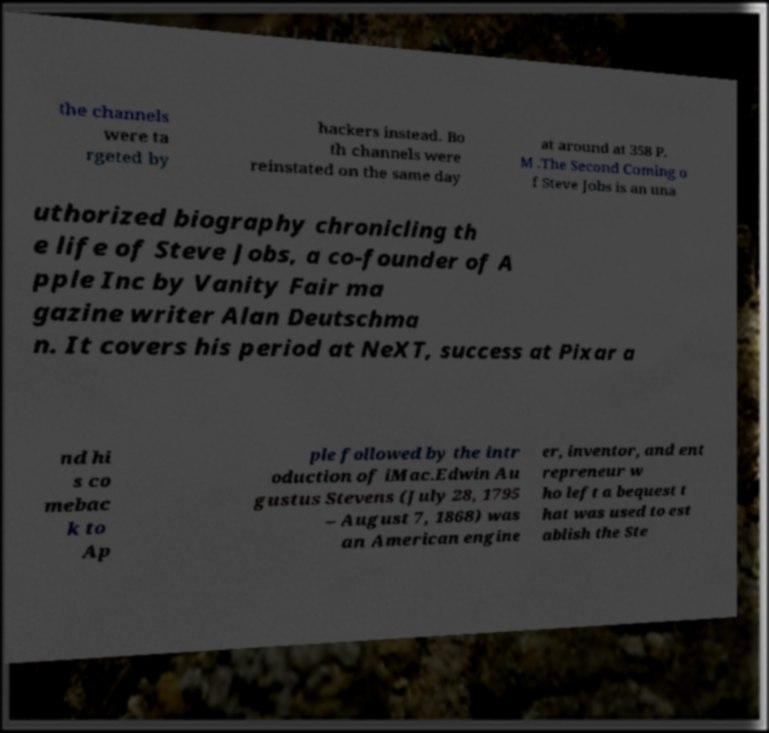Can you accurately transcribe the text from the provided image for me? the channels were ta rgeted by hackers instead. Bo th channels were reinstated on the same day at around at 358 P. M .The Second Coming o f Steve Jobs is an una uthorized biography chronicling th e life of Steve Jobs, a co-founder of A pple Inc by Vanity Fair ma gazine writer Alan Deutschma n. It covers his period at NeXT, success at Pixar a nd hi s co mebac k to Ap ple followed by the intr oduction of iMac.Edwin Au gustus Stevens (July 28, 1795 – August 7, 1868) was an American engine er, inventor, and ent repreneur w ho left a bequest t hat was used to est ablish the Ste 